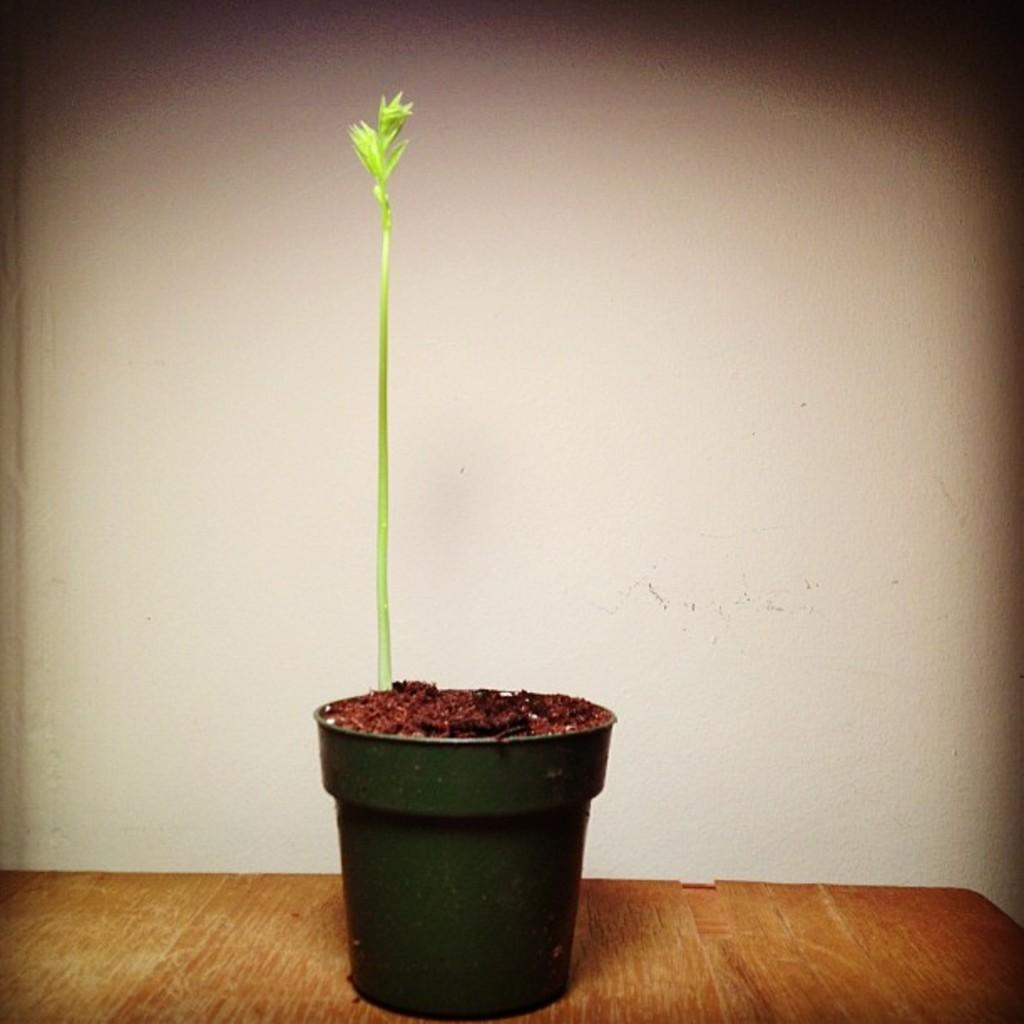What object is visible in the image that contains plants? There is a flower pot in the image that contains plants. Where is the flower pot located? The flower pot is on the floor. What can be seen in the background of the image? There is a wall in the background of the image. What type of insect is crawling on the man's shoulder in the image? There is no man or insect present in the image; it features a flower pot with plants on the floor and a wall in the background. 